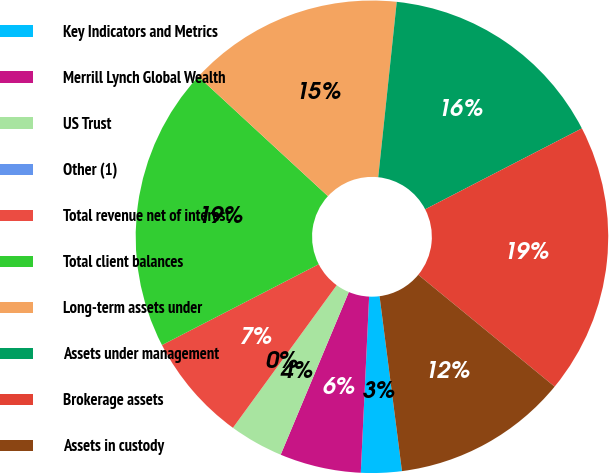Convert chart. <chart><loc_0><loc_0><loc_500><loc_500><pie_chart><fcel>Key Indicators and Metrics<fcel>Merrill Lynch Global Wealth<fcel>US Trust<fcel>Other (1)<fcel>Total revenue net of interest<fcel>Total client balances<fcel>Long-term assets under<fcel>Assets under management<fcel>Brokerage assets<fcel>Assets in custody<nl><fcel>2.78%<fcel>5.56%<fcel>3.7%<fcel>0.0%<fcel>7.41%<fcel>19.44%<fcel>14.81%<fcel>15.74%<fcel>18.52%<fcel>12.04%<nl></chart> 